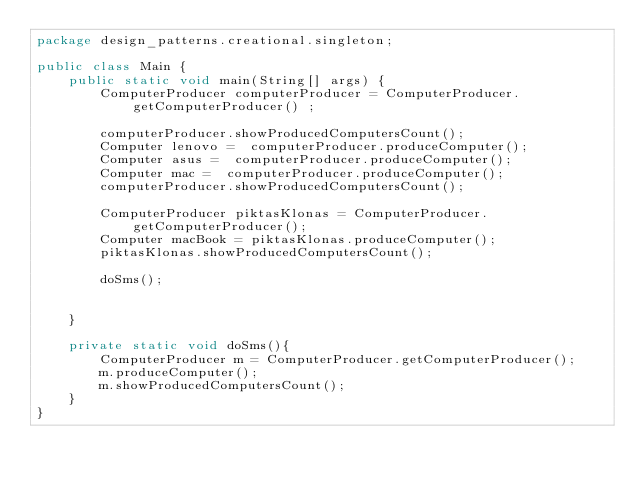<code> <loc_0><loc_0><loc_500><loc_500><_Java_>package design_patterns.creational.singleton;

public class Main {
    public static void main(String[] args) {
        ComputerProducer computerProducer = ComputerProducer.getComputerProducer() ;

        computerProducer.showProducedComputersCount();
        Computer lenovo =  computerProducer.produceComputer();
        Computer asus =  computerProducer.produceComputer();
        Computer mac =  computerProducer.produceComputer();
        computerProducer.showProducedComputersCount();

        ComputerProducer piktasKlonas = ComputerProducer.getComputerProducer();
        Computer macBook = piktasKlonas.produceComputer();
        piktasKlonas.showProducedComputersCount();

        doSms();


    }

    private static void doSms(){
        ComputerProducer m = ComputerProducer.getComputerProducer();
        m.produceComputer();
        m.showProducedComputersCount();
    }
}
</code> 